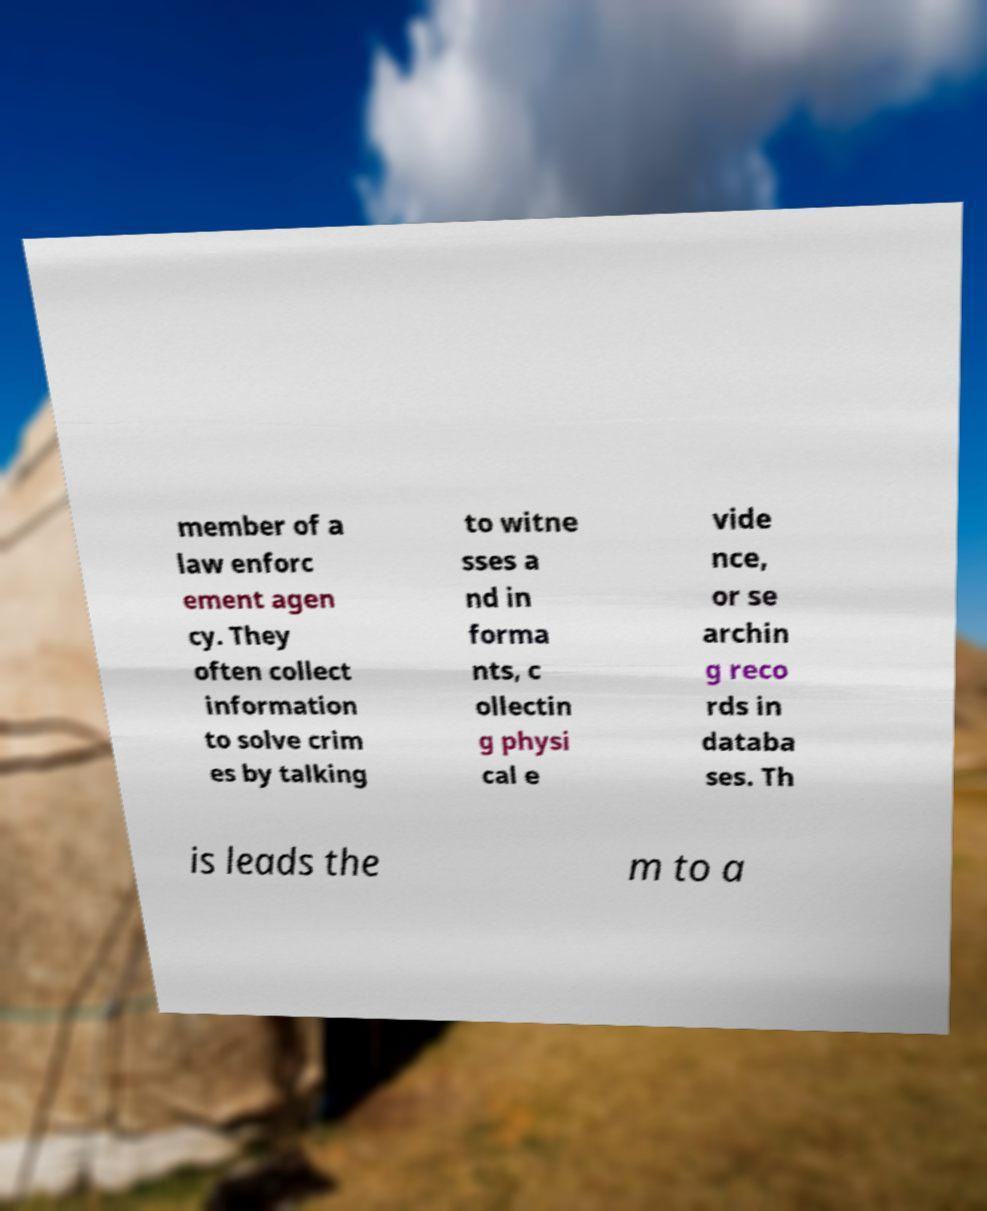I need the written content from this picture converted into text. Can you do that? member of a law enforc ement agen cy. They often collect information to solve crim es by talking to witne sses a nd in forma nts, c ollectin g physi cal e vide nce, or se archin g reco rds in databa ses. Th is leads the m to a 